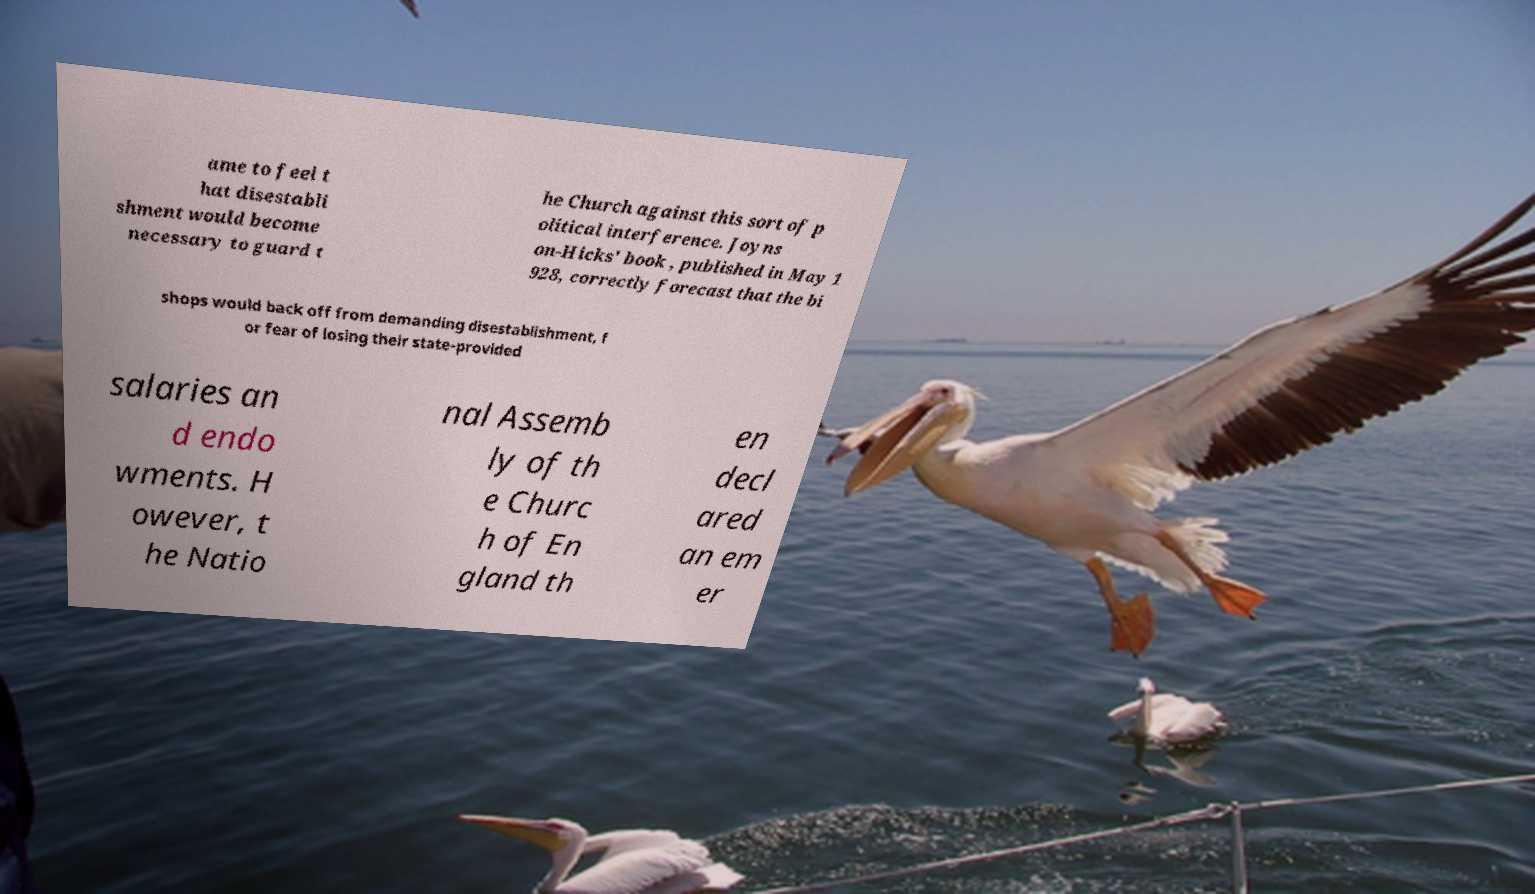I need the written content from this picture converted into text. Can you do that? ame to feel t hat disestabli shment would become necessary to guard t he Church against this sort of p olitical interference. Joyns on-Hicks' book , published in May 1 928, correctly forecast that the bi shops would back off from demanding disestablishment, f or fear of losing their state-provided salaries an d endo wments. H owever, t he Natio nal Assemb ly of th e Churc h of En gland th en decl ared an em er 